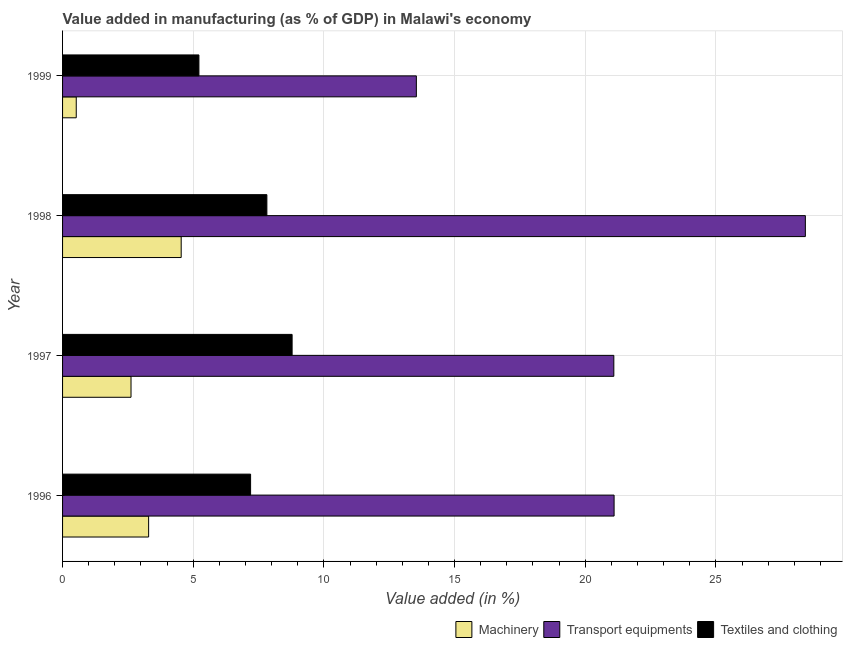How many groups of bars are there?
Give a very brief answer. 4. Are the number of bars on each tick of the Y-axis equal?
Give a very brief answer. Yes. How many bars are there on the 1st tick from the top?
Make the answer very short. 3. What is the label of the 2nd group of bars from the top?
Offer a very short reply. 1998. In how many cases, is the number of bars for a given year not equal to the number of legend labels?
Provide a succinct answer. 0. What is the value added in manufacturing transport equipments in 1996?
Give a very brief answer. 21.1. Across all years, what is the maximum value added in manufacturing textile and clothing?
Make the answer very short. 8.78. Across all years, what is the minimum value added in manufacturing textile and clothing?
Provide a short and direct response. 5.22. In which year was the value added in manufacturing machinery minimum?
Offer a terse response. 1999. What is the total value added in manufacturing machinery in the graph?
Your response must be concise. 10.98. What is the difference between the value added in manufacturing machinery in 1996 and that in 1998?
Give a very brief answer. -1.25. What is the difference between the value added in manufacturing machinery in 1997 and the value added in manufacturing transport equipments in 1999?
Make the answer very short. -10.92. What is the average value added in manufacturing machinery per year?
Give a very brief answer. 2.74. In the year 1996, what is the difference between the value added in manufacturing textile and clothing and value added in manufacturing machinery?
Keep it short and to the point. 3.9. In how many years, is the value added in manufacturing textile and clothing greater than 26 %?
Offer a very short reply. 0. What is the ratio of the value added in manufacturing textile and clothing in 1997 to that in 1998?
Offer a very short reply. 1.12. Is the value added in manufacturing machinery in 1996 less than that in 1999?
Make the answer very short. No. Is the difference between the value added in manufacturing transport equipments in 1996 and 1999 greater than the difference between the value added in manufacturing machinery in 1996 and 1999?
Provide a short and direct response. Yes. What is the difference between the highest and the second highest value added in manufacturing transport equipments?
Your answer should be compact. 7.32. What is the difference between the highest and the lowest value added in manufacturing machinery?
Provide a succinct answer. 4.02. Is the sum of the value added in manufacturing transport equipments in 1998 and 1999 greater than the maximum value added in manufacturing machinery across all years?
Provide a succinct answer. Yes. What does the 3rd bar from the top in 1998 represents?
Make the answer very short. Machinery. What does the 3rd bar from the bottom in 1998 represents?
Keep it short and to the point. Textiles and clothing. Is it the case that in every year, the sum of the value added in manufacturing machinery and value added in manufacturing transport equipments is greater than the value added in manufacturing textile and clothing?
Offer a very short reply. Yes. Are all the bars in the graph horizontal?
Your answer should be very brief. Yes. How many years are there in the graph?
Your response must be concise. 4. Are the values on the major ticks of X-axis written in scientific E-notation?
Make the answer very short. No. Where does the legend appear in the graph?
Offer a terse response. Bottom right. How many legend labels are there?
Ensure brevity in your answer.  3. How are the legend labels stacked?
Give a very brief answer. Horizontal. What is the title of the graph?
Offer a terse response. Value added in manufacturing (as % of GDP) in Malawi's economy. Does "Ages 15-64" appear as one of the legend labels in the graph?
Make the answer very short. No. What is the label or title of the X-axis?
Make the answer very short. Value added (in %). What is the label or title of the Y-axis?
Make the answer very short. Year. What is the Value added (in %) in Machinery in 1996?
Make the answer very short. 3.29. What is the Value added (in %) of Transport equipments in 1996?
Provide a short and direct response. 21.1. What is the Value added (in %) in Textiles and clothing in 1996?
Give a very brief answer. 7.19. What is the Value added (in %) in Machinery in 1997?
Make the answer very short. 2.62. What is the Value added (in %) of Transport equipments in 1997?
Your answer should be very brief. 21.09. What is the Value added (in %) in Textiles and clothing in 1997?
Your response must be concise. 8.78. What is the Value added (in %) in Machinery in 1998?
Keep it short and to the point. 4.54. What is the Value added (in %) in Transport equipments in 1998?
Your answer should be very brief. 28.42. What is the Value added (in %) of Textiles and clothing in 1998?
Your answer should be very brief. 7.82. What is the Value added (in %) of Machinery in 1999?
Make the answer very short. 0.52. What is the Value added (in %) of Transport equipments in 1999?
Offer a terse response. 13.54. What is the Value added (in %) in Textiles and clothing in 1999?
Ensure brevity in your answer.  5.22. Across all years, what is the maximum Value added (in %) of Machinery?
Give a very brief answer. 4.54. Across all years, what is the maximum Value added (in %) of Transport equipments?
Make the answer very short. 28.42. Across all years, what is the maximum Value added (in %) in Textiles and clothing?
Offer a terse response. 8.78. Across all years, what is the minimum Value added (in %) in Machinery?
Give a very brief answer. 0.52. Across all years, what is the minimum Value added (in %) of Transport equipments?
Keep it short and to the point. 13.54. Across all years, what is the minimum Value added (in %) in Textiles and clothing?
Your answer should be very brief. 5.22. What is the total Value added (in %) in Machinery in the graph?
Keep it short and to the point. 10.98. What is the total Value added (in %) in Transport equipments in the graph?
Your response must be concise. 84.16. What is the total Value added (in %) of Textiles and clothing in the graph?
Ensure brevity in your answer.  29.01. What is the difference between the Value added (in %) of Machinery in 1996 and that in 1997?
Offer a very short reply. 0.67. What is the difference between the Value added (in %) in Transport equipments in 1996 and that in 1997?
Your response must be concise. 0.01. What is the difference between the Value added (in %) in Textiles and clothing in 1996 and that in 1997?
Your response must be concise. -1.59. What is the difference between the Value added (in %) of Machinery in 1996 and that in 1998?
Give a very brief answer. -1.25. What is the difference between the Value added (in %) in Transport equipments in 1996 and that in 1998?
Your answer should be compact. -7.32. What is the difference between the Value added (in %) of Textiles and clothing in 1996 and that in 1998?
Your answer should be very brief. -0.62. What is the difference between the Value added (in %) of Machinery in 1996 and that in 1999?
Your answer should be compact. 2.77. What is the difference between the Value added (in %) in Transport equipments in 1996 and that in 1999?
Provide a succinct answer. 7.57. What is the difference between the Value added (in %) of Textiles and clothing in 1996 and that in 1999?
Provide a short and direct response. 1.98. What is the difference between the Value added (in %) in Machinery in 1997 and that in 1998?
Offer a very short reply. -1.92. What is the difference between the Value added (in %) of Transport equipments in 1997 and that in 1998?
Your response must be concise. -7.33. What is the difference between the Value added (in %) of Textiles and clothing in 1997 and that in 1998?
Your answer should be very brief. 0.97. What is the difference between the Value added (in %) of Machinery in 1997 and that in 1999?
Your response must be concise. 2.1. What is the difference between the Value added (in %) of Transport equipments in 1997 and that in 1999?
Provide a short and direct response. 7.56. What is the difference between the Value added (in %) of Textiles and clothing in 1997 and that in 1999?
Provide a short and direct response. 3.57. What is the difference between the Value added (in %) in Machinery in 1998 and that in 1999?
Your answer should be compact. 4.02. What is the difference between the Value added (in %) in Transport equipments in 1998 and that in 1999?
Your answer should be very brief. 14.88. What is the difference between the Value added (in %) in Textiles and clothing in 1998 and that in 1999?
Your answer should be very brief. 2.6. What is the difference between the Value added (in %) of Machinery in 1996 and the Value added (in %) of Transport equipments in 1997?
Ensure brevity in your answer.  -17.8. What is the difference between the Value added (in %) in Machinery in 1996 and the Value added (in %) in Textiles and clothing in 1997?
Offer a very short reply. -5.49. What is the difference between the Value added (in %) in Transport equipments in 1996 and the Value added (in %) in Textiles and clothing in 1997?
Offer a terse response. 12.32. What is the difference between the Value added (in %) in Machinery in 1996 and the Value added (in %) in Transport equipments in 1998?
Offer a terse response. -25.13. What is the difference between the Value added (in %) of Machinery in 1996 and the Value added (in %) of Textiles and clothing in 1998?
Your answer should be very brief. -4.52. What is the difference between the Value added (in %) in Transport equipments in 1996 and the Value added (in %) in Textiles and clothing in 1998?
Provide a short and direct response. 13.29. What is the difference between the Value added (in %) of Machinery in 1996 and the Value added (in %) of Transport equipments in 1999?
Make the answer very short. -10.24. What is the difference between the Value added (in %) in Machinery in 1996 and the Value added (in %) in Textiles and clothing in 1999?
Make the answer very short. -1.92. What is the difference between the Value added (in %) in Transport equipments in 1996 and the Value added (in %) in Textiles and clothing in 1999?
Make the answer very short. 15.89. What is the difference between the Value added (in %) of Machinery in 1997 and the Value added (in %) of Transport equipments in 1998?
Your answer should be compact. -25.8. What is the difference between the Value added (in %) in Machinery in 1997 and the Value added (in %) in Textiles and clothing in 1998?
Offer a very short reply. -5.2. What is the difference between the Value added (in %) of Transport equipments in 1997 and the Value added (in %) of Textiles and clothing in 1998?
Offer a very short reply. 13.28. What is the difference between the Value added (in %) in Machinery in 1997 and the Value added (in %) in Transport equipments in 1999?
Your answer should be very brief. -10.92. What is the difference between the Value added (in %) in Machinery in 1997 and the Value added (in %) in Textiles and clothing in 1999?
Your response must be concise. -2.6. What is the difference between the Value added (in %) of Transport equipments in 1997 and the Value added (in %) of Textiles and clothing in 1999?
Offer a terse response. 15.88. What is the difference between the Value added (in %) of Machinery in 1998 and the Value added (in %) of Transport equipments in 1999?
Your response must be concise. -9. What is the difference between the Value added (in %) in Machinery in 1998 and the Value added (in %) in Textiles and clothing in 1999?
Provide a short and direct response. -0.68. What is the difference between the Value added (in %) of Transport equipments in 1998 and the Value added (in %) of Textiles and clothing in 1999?
Offer a very short reply. 23.2. What is the average Value added (in %) in Machinery per year?
Your answer should be very brief. 2.74. What is the average Value added (in %) in Transport equipments per year?
Make the answer very short. 21.04. What is the average Value added (in %) in Textiles and clothing per year?
Your response must be concise. 7.25. In the year 1996, what is the difference between the Value added (in %) in Machinery and Value added (in %) in Transport equipments?
Provide a succinct answer. -17.81. In the year 1996, what is the difference between the Value added (in %) in Machinery and Value added (in %) in Textiles and clothing?
Offer a terse response. -3.9. In the year 1996, what is the difference between the Value added (in %) of Transport equipments and Value added (in %) of Textiles and clothing?
Make the answer very short. 13.91. In the year 1997, what is the difference between the Value added (in %) in Machinery and Value added (in %) in Transport equipments?
Offer a terse response. -18.47. In the year 1997, what is the difference between the Value added (in %) in Machinery and Value added (in %) in Textiles and clothing?
Provide a succinct answer. -6.16. In the year 1997, what is the difference between the Value added (in %) of Transport equipments and Value added (in %) of Textiles and clothing?
Your response must be concise. 12.31. In the year 1998, what is the difference between the Value added (in %) in Machinery and Value added (in %) in Transport equipments?
Keep it short and to the point. -23.88. In the year 1998, what is the difference between the Value added (in %) of Machinery and Value added (in %) of Textiles and clothing?
Offer a very short reply. -3.28. In the year 1998, what is the difference between the Value added (in %) of Transport equipments and Value added (in %) of Textiles and clothing?
Your answer should be very brief. 20.6. In the year 1999, what is the difference between the Value added (in %) in Machinery and Value added (in %) in Transport equipments?
Your answer should be very brief. -13.01. In the year 1999, what is the difference between the Value added (in %) in Machinery and Value added (in %) in Textiles and clothing?
Offer a very short reply. -4.69. In the year 1999, what is the difference between the Value added (in %) in Transport equipments and Value added (in %) in Textiles and clothing?
Keep it short and to the point. 8.32. What is the ratio of the Value added (in %) in Machinery in 1996 to that in 1997?
Your answer should be very brief. 1.26. What is the ratio of the Value added (in %) in Textiles and clothing in 1996 to that in 1997?
Keep it short and to the point. 0.82. What is the ratio of the Value added (in %) in Machinery in 1996 to that in 1998?
Your answer should be compact. 0.73. What is the ratio of the Value added (in %) in Transport equipments in 1996 to that in 1998?
Ensure brevity in your answer.  0.74. What is the ratio of the Value added (in %) of Textiles and clothing in 1996 to that in 1998?
Your response must be concise. 0.92. What is the ratio of the Value added (in %) in Machinery in 1996 to that in 1999?
Ensure brevity in your answer.  6.29. What is the ratio of the Value added (in %) of Transport equipments in 1996 to that in 1999?
Make the answer very short. 1.56. What is the ratio of the Value added (in %) of Textiles and clothing in 1996 to that in 1999?
Make the answer very short. 1.38. What is the ratio of the Value added (in %) of Machinery in 1997 to that in 1998?
Ensure brevity in your answer.  0.58. What is the ratio of the Value added (in %) of Transport equipments in 1997 to that in 1998?
Your answer should be compact. 0.74. What is the ratio of the Value added (in %) of Textiles and clothing in 1997 to that in 1998?
Your answer should be very brief. 1.12. What is the ratio of the Value added (in %) of Machinery in 1997 to that in 1999?
Give a very brief answer. 5. What is the ratio of the Value added (in %) of Transport equipments in 1997 to that in 1999?
Your response must be concise. 1.56. What is the ratio of the Value added (in %) of Textiles and clothing in 1997 to that in 1999?
Keep it short and to the point. 1.68. What is the ratio of the Value added (in %) of Machinery in 1998 to that in 1999?
Make the answer very short. 8.67. What is the ratio of the Value added (in %) of Transport equipments in 1998 to that in 1999?
Offer a very short reply. 2.1. What is the ratio of the Value added (in %) in Textiles and clothing in 1998 to that in 1999?
Give a very brief answer. 1.5. What is the difference between the highest and the second highest Value added (in %) in Machinery?
Ensure brevity in your answer.  1.25. What is the difference between the highest and the second highest Value added (in %) in Transport equipments?
Make the answer very short. 7.32. What is the difference between the highest and the second highest Value added (in %) of Textiles and clothing?
Your answer should be very brief. 0.97. What is the difference between the highest and the lowest Value added (in %) in Machinery?
Ensure brevity in your answer.  4.02. What is the difference between the highest and the lowest Value added (in %) of Transport equipments?
Give a very brief answer. 14.88. What is the difference between the highest and the lowest Value added (in %) in Textiles and clothing?
Offer a very short reply. 3.57. 